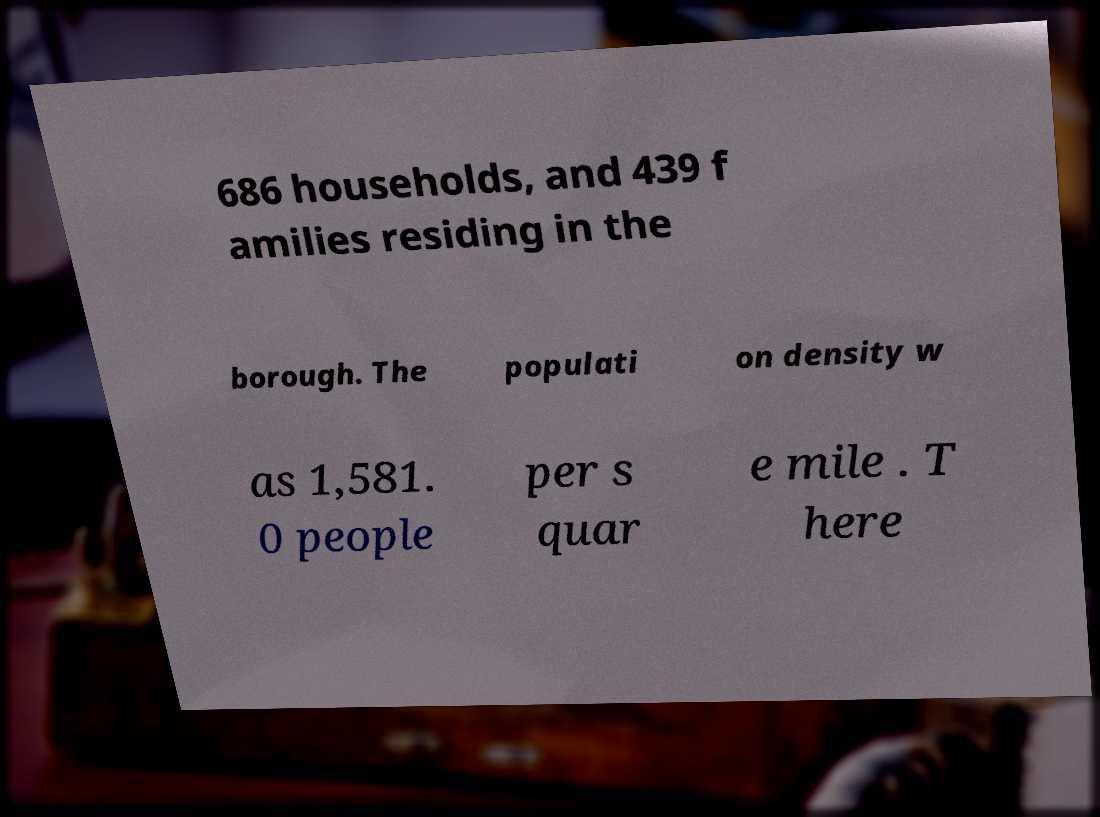Could you assist in decoding the text presented in this image and type it out clearly? 686 households, and 439 f amilies residing in the borough. The populati on density w as 1,581. 0 people per s quar e mile . T here 